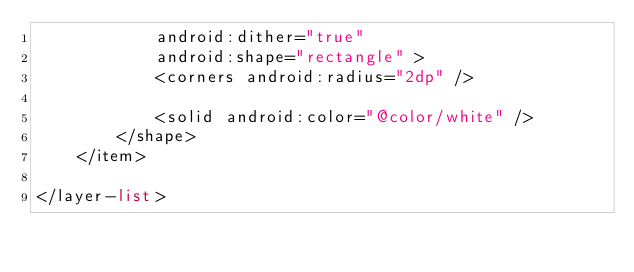<code> <loc_0><loc_0><loc_500><loc_500><_XML_>            android:dither="true"
            android:shape="rectangle" >
            <corners android:radius="2dp" />

            <solid android:color="@color/white" />
        </shape>
    </item>

</layer-list></code> 